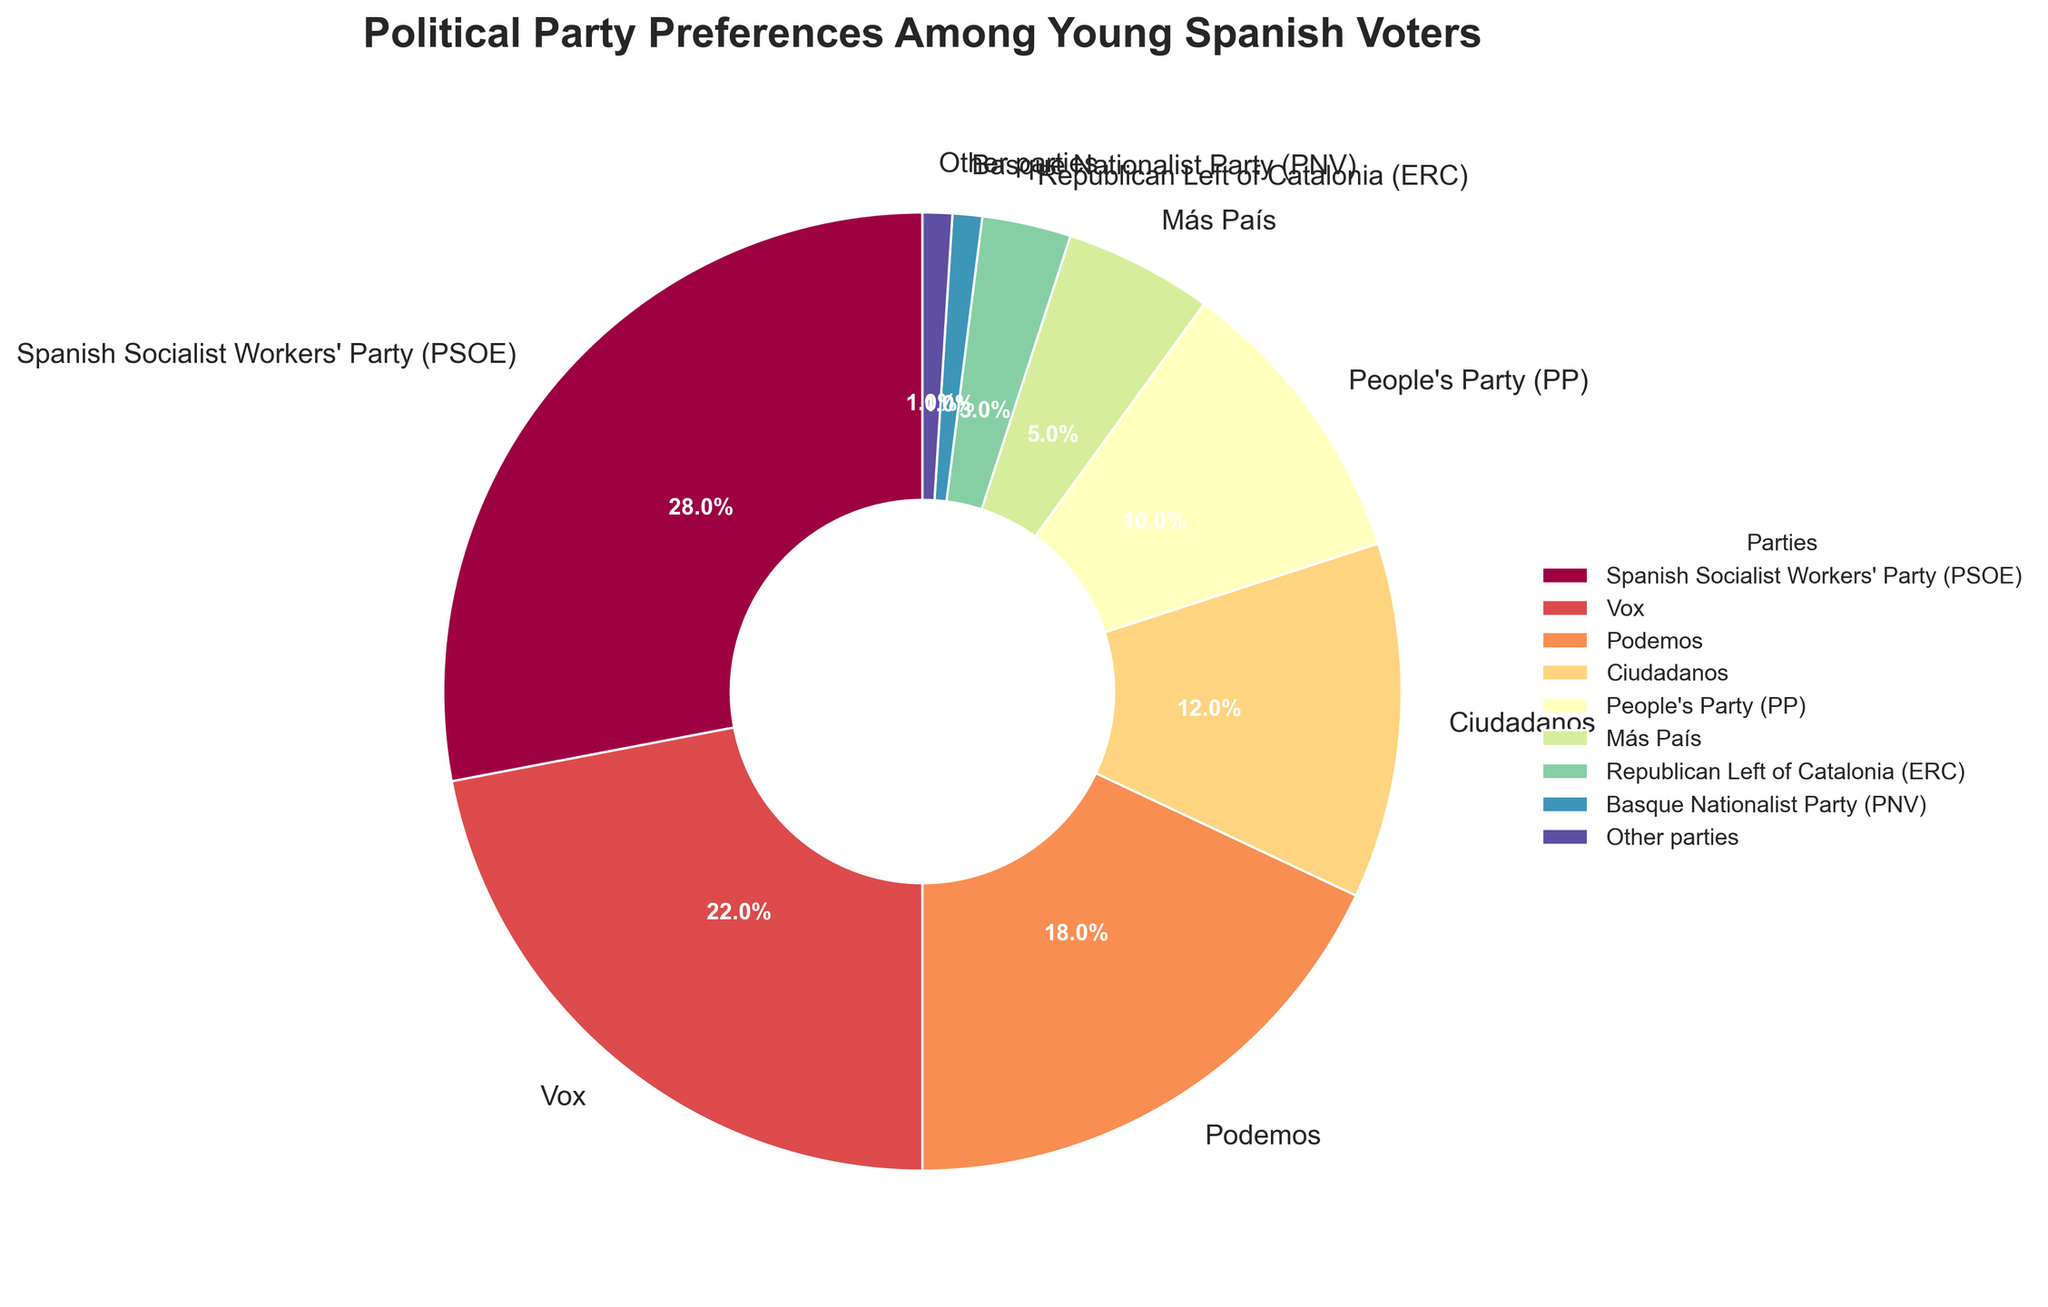Which party has the highest percentage of preferences among young Spanish voters? The Spanish Socialist Workers' Party (PSOE) has the highest percentage at 28% according to the pie chart. Therefore, PSOE has the highest preference.
Answer: Spanish Socialist Workers' Party (PSOE) How much higher is the preference percentage for Vox compared to the People's Party (PP)? Vox's percentage is 22%, and PP's is 10%. Subtracting PP's percentage from Vox's, 22% - 10% = 12%.
Answer: 12% Which party has a lower preference percentage: Ciudadanos or Podemos? According to the pie chart, Ciudadanos has 12% and Podemos has 18%. Ciudadanos has a lower preference percentage than Podemos.
Answer: Ciudadanos What is the combined percentage of preferences for parties with percentages below 5%? The parties with percentages below 5% are Más País (5%), Republican Left of Catalonia (ERC) (3%), Basque Nationalist Party (PNV) (1%), and Other parties (1%). Summing these up, 5% + 3% + 1% + 1% = 10%.
Answer: 10% Which party's wedge color is food-blue, and what is its percentage? In the pie chart, the widget with a pale blue color corresponds to the People's Party (PP), which has a 10% preference among young Spanish voters.
Answer: People's Party (PP) Among the political parties listed, which has the smallest preference percentage? According to the pie chart, both the Basque Nationalist Party (PNV) and Other parties have the smallest preference percentage at 1%.
Answer: Basque Nationalist Party (PNV) and Other parties Which regions' party has the least combined preference percentage: the Republican Left of Catalonia (ERC) or the Basque Nationalist Party (PNV)? ERC's percentage is 3%, while PNV's is 1%. Therefore, the Basque Nationalist Party (PNV) has the least combined preference percentage.
Answer: Basque Nationalist Party (PNV) What's the sum of the preferences for the top three most preferred political parties? The top three most preferred parties are Spanish Socialist Workers' Party (PSOE) with 28%, Vox with 22%, and Podemos with 18%. Summing them up results in 28% + 22% + 18% = 68%.
Answer: 68% Is the combined preference percentage of Podemos and Vox larger than that of PSOE alone? Podemos has 18%, and Vox has 22%. Adding these, we get 18% + 22% = 40%. Comparing this to PSOE's 28%, we see that 40% > 28%.
Answer: Yes By how many percentage points does the preference for the Spanish Socialist Workers' Party (PSOE) exceed the combined total of Más País, ERC, PNV, and Other parties? PSOE's preference is 28%. The combined total of Más País (5%), ERC (3%), PNV (1%), and Other parties (1%) is 5% + 3% + 1% + 1% = 10%. Subtracting the combined total from PSOE's percentage, we get 28% - 10% = 18%.
Answer: 18% 